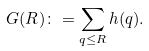<formula> <loc_0><loc_0><loc_500><loc_500>G ( R ) \colon = \sum _ { q \leq R } h ( q ) .</formula> 